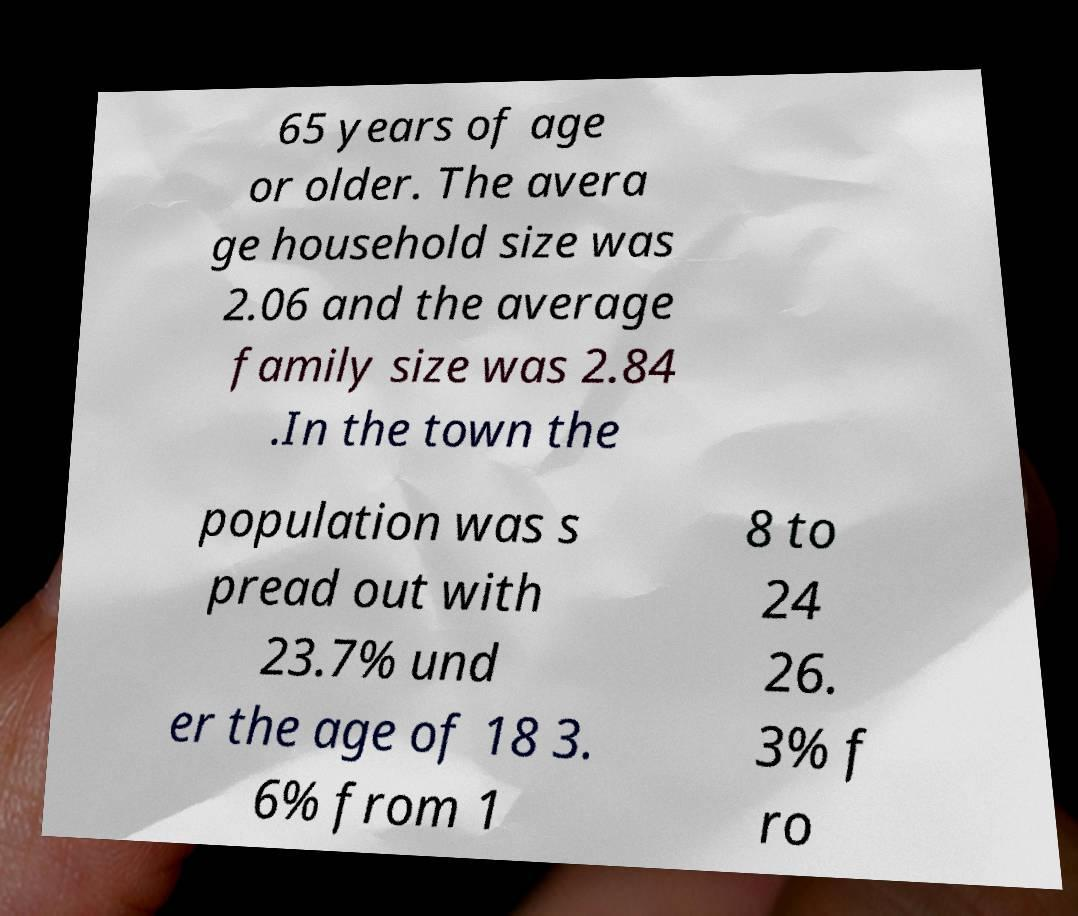Can you read and provide the text displayed in the image?This photo seems to have some interesting text. Can you extract and type it out for me? 65 years of age or older. The avera ge household size was 2.06 and the average family size was 2.84 .In the town the population was s pread out with 23.7% und er the age of 18 3. 6% from 1 8 to 24 26. 3% f ro 